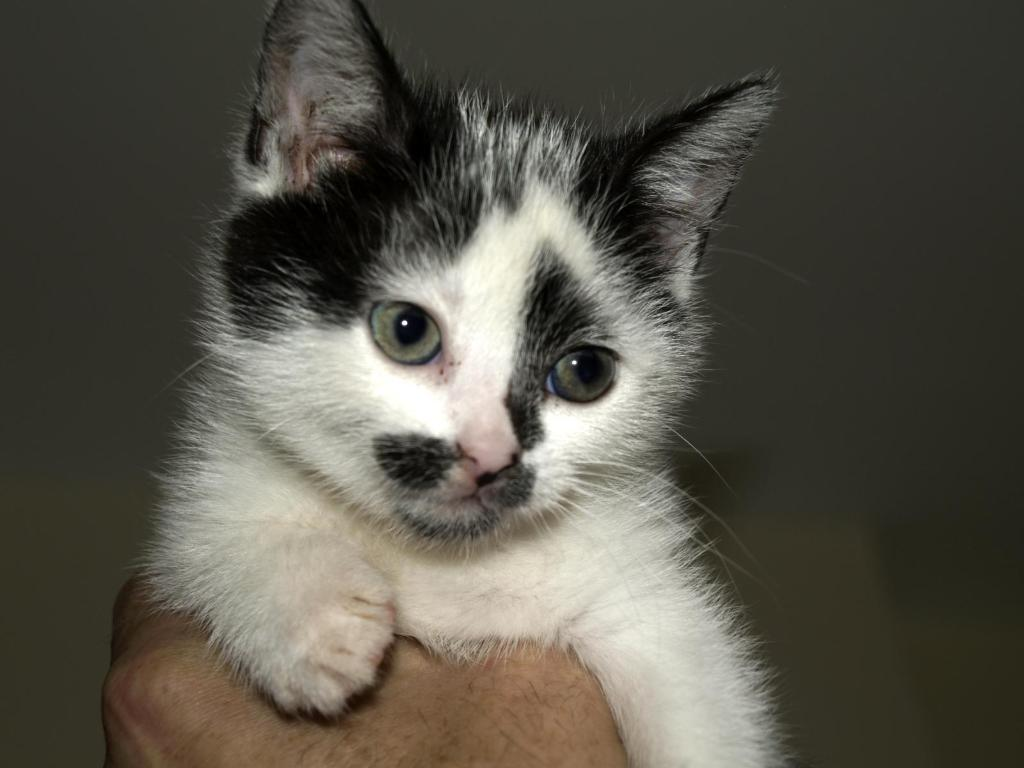What is visible in the image? There is a person's hand in the image. What is the hand holding? The hand is holding a cat. What type of metal is the seed being transported in the image? There is no metal, seed, or transport depicted in the image; it only shows a person's hand holding a cat. 